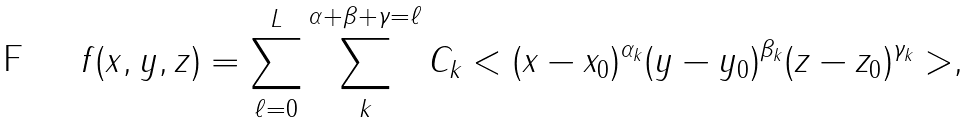Convert formula to latex. <formula><loc_0><loc_0><loc_500><loc_500>f ( x , y , z ) = \sum _ { \ell = 0 } ^ { L } \sum _ { k } ^ { \alpha + \beta + \gamma = \ell } C _ { k } < ( x - x _ { 0 } ) ^ { \alpha _ { k } } ( y - y _ { 0 } ) ^ { \beta _ { k } } ( z - z _ { 0 } ) ^ { \gamma _ { k } } > ,</formula> 